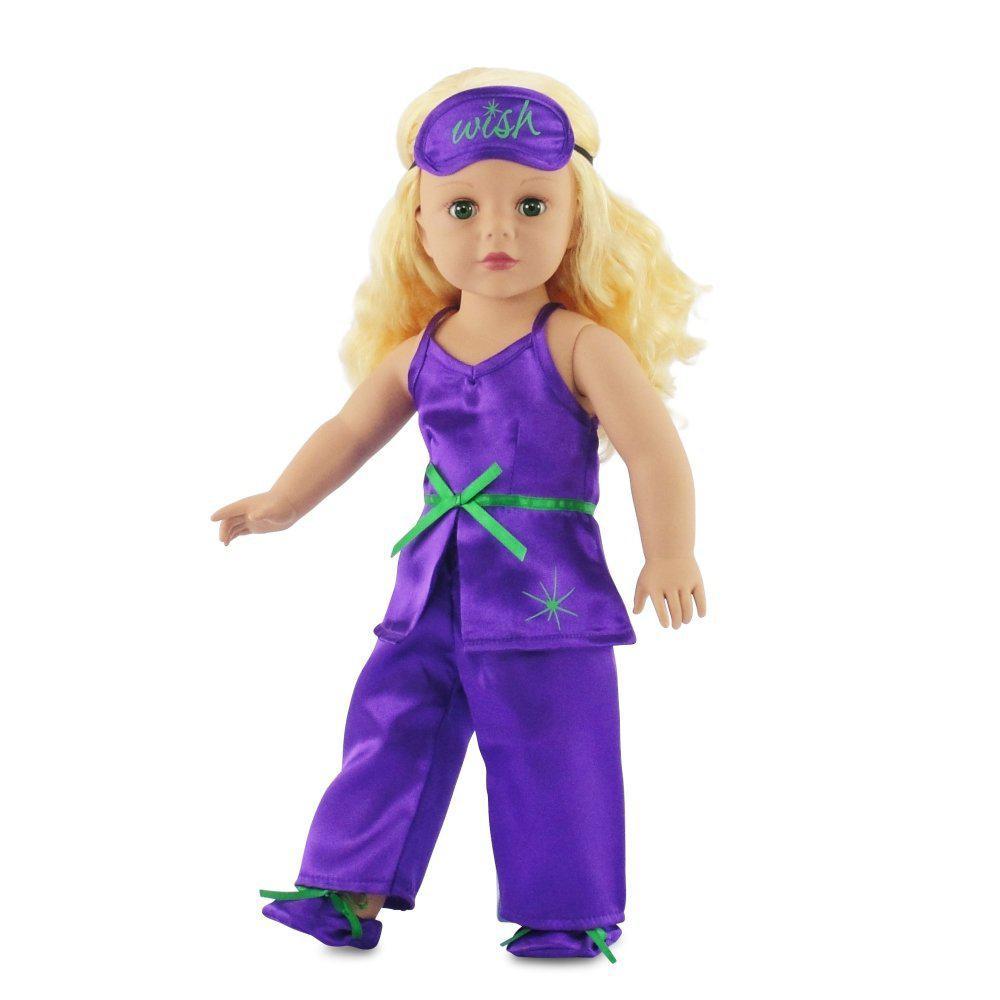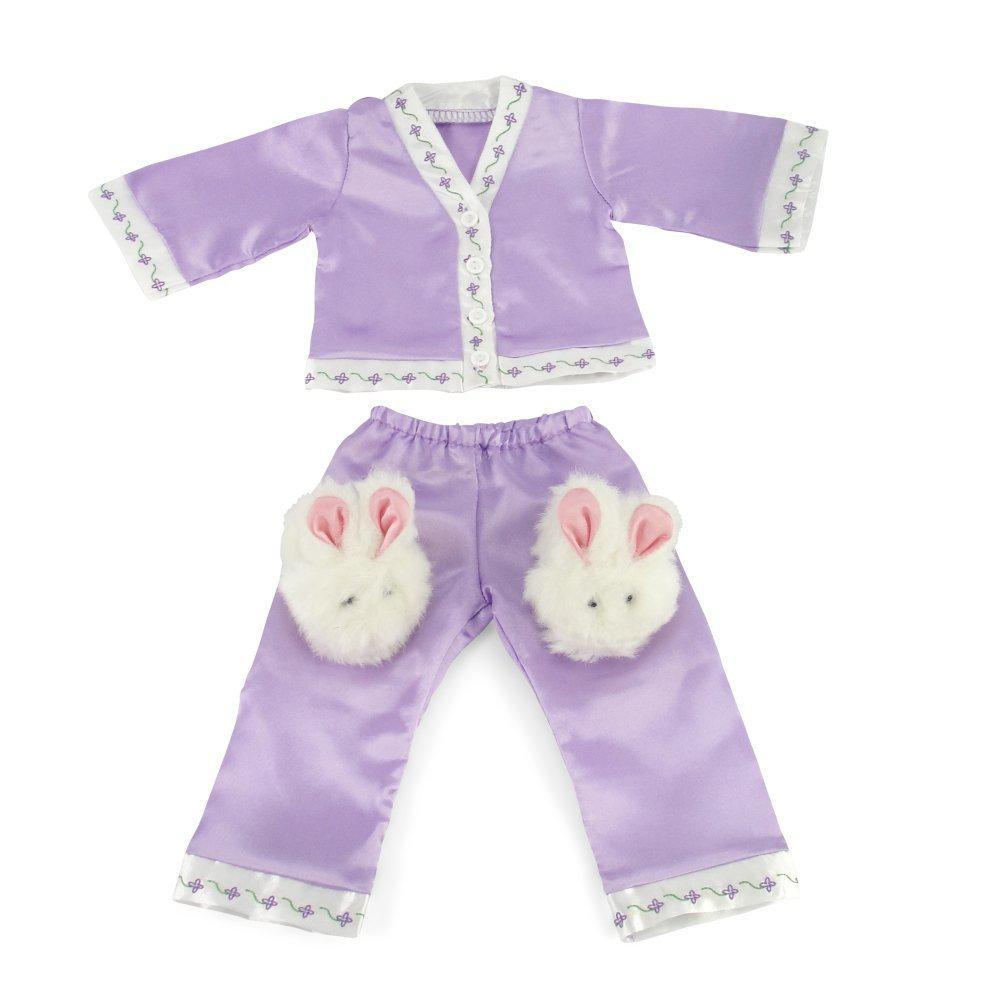The first image is the image on the left, the second image is the image on the right. Given the left and right images, does the statement "One image shows a doll wearing her hair in pigtails." hold true? Answer yes or no. No. The first image is the image on the left, the second image is the image on the right. For the images displayed, is the sentence "there is a doll in pajamas and wearing white bunny slippers" factually correct? Answer yes or no. No. 